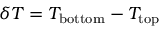Convert formula to latex. <formula><loc_0><loc_0><loc_500><loc_500>\delta T = T _ { b o t t o m } - T _ { t o p }</formula> 